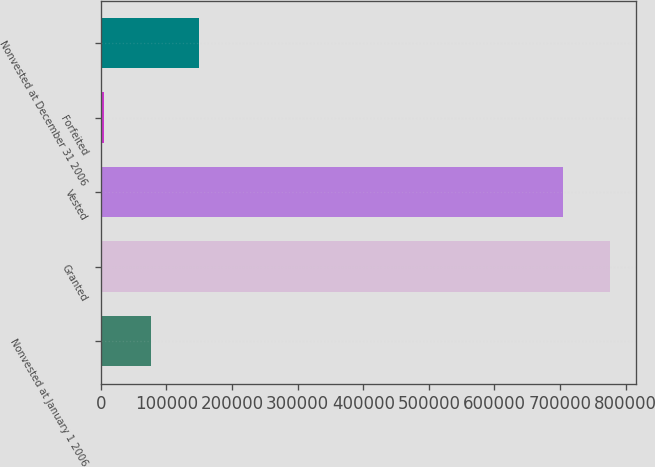Convert chart to OTSL. <chart><loc_0><loc_0><loc_500><loc_500><bar_chart><fcel>Nonvested at January 1 2006<fcel>Granted<fcel>Vested<fcel>Forfeited<fcel>Nonvested at December 31 2006<nl><fcel>77038.2<fcel>776331<fcel>704385<fcel>5092<fcel>148984<nl></chart> 